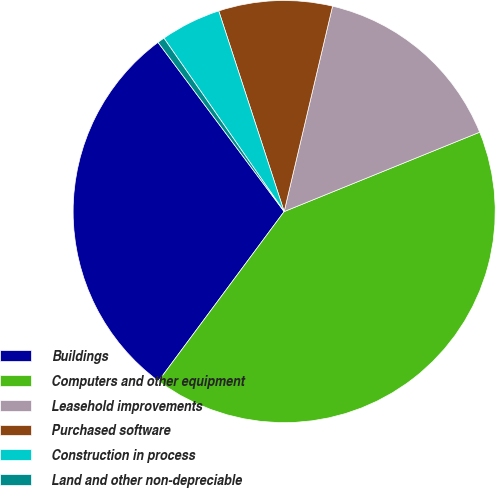Convert chart. <chart><loc_0><loc_0><loc_500><loc_500><pie_chart><fcel>Buildings<fcel>Computers and other equipment<fcel>Leasehold improvements<fcel>Purchased software<fcel>Construction in process<fcel>Land and other non-depreciable<nl><fcel>29.65%<fcel>41.29%<fcel>15.18%<fcel>8.7%<fcel>4.63%<fcel>0.55%<nl></chart> 